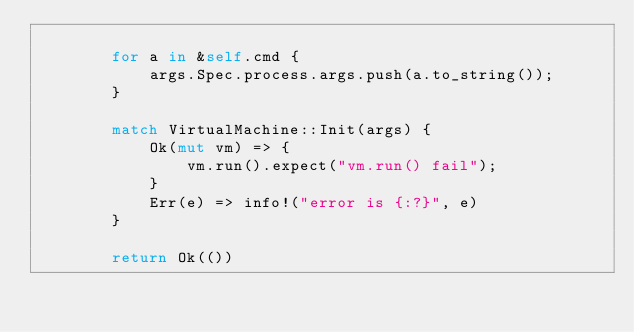<code> <loc_0><loc_0><loc_500><loc_500><_Rust_>
        for a in &self.cmd {
            args.Spec.process.args.push(a.to_string());
        }

        match VirtualMachine::Init(args) {
            Ok(mut vm) => {
                vm.run().expect("vm.run() fail");
            }
            Err(e) => info!("error is {:?}", e)
        }

        return Ok(())</code> 